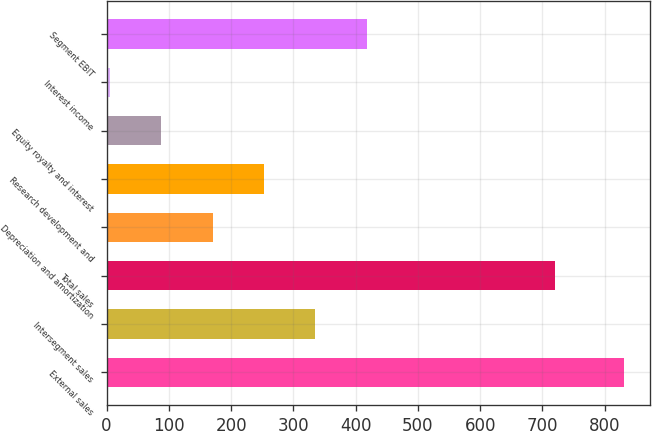<chart> <loc_0><loc_0><loc_500><loc_500><bar_chart><fcel>External sales<fcel>Intersegment sales<fcel>Total sales<fcel>Depreciation and amortization<fcel>Research development and<fcel>Equity royalty and interest<fcel>Interest income<fcel>Segment EBIT<nl><fcel>831<fcel>335.4<fcel>720<fcel>170.2<fcel>252.8<fcel>87.6<fcel>5<fcel>418<nl></chart> 